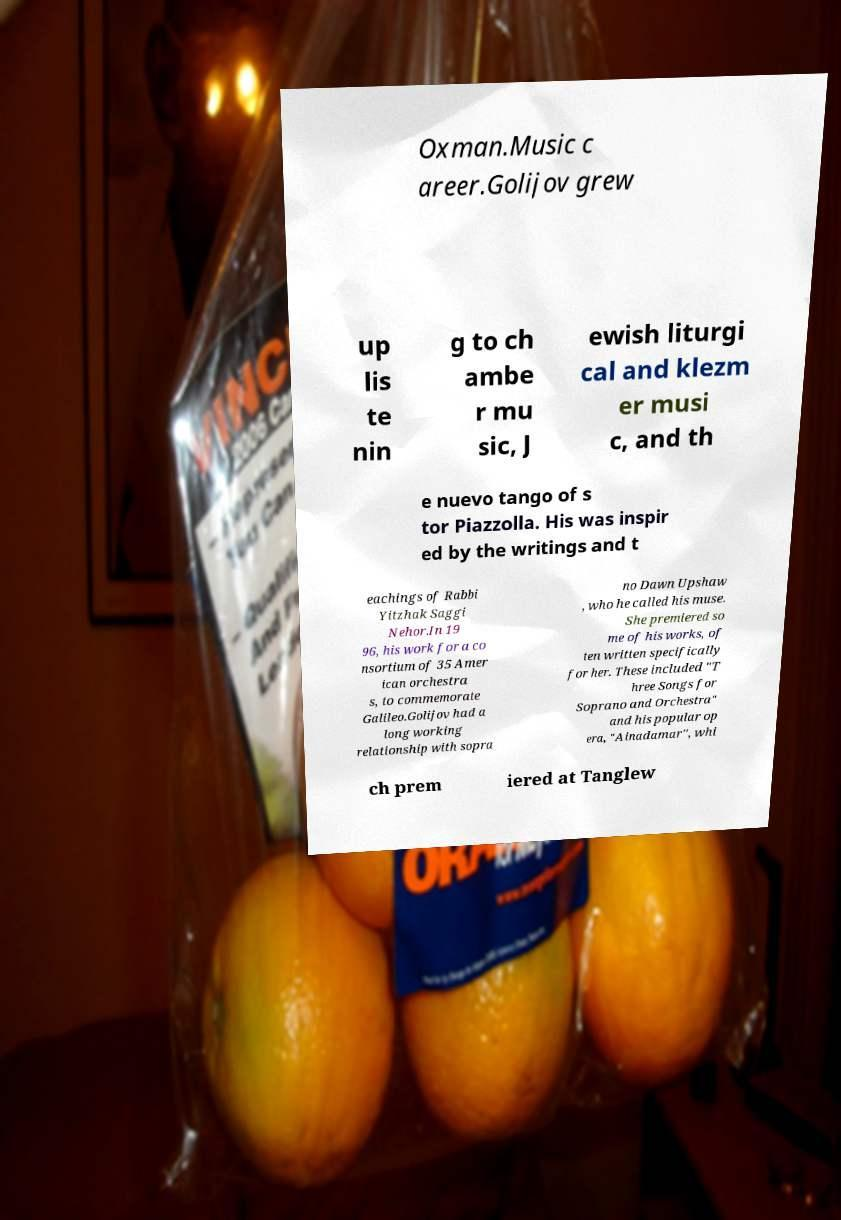Can you read and provide the text displayed in the image?This photo seems to have some interesting text. Can you extract and type it out for me? Oxman.Music c areer.Golijov grew up lis te nin g to ch ambe r mu sic, J ewish liturgi cal and klezm er musi c, and th e nuevo tango of s tor Piazzolla. His was inspir ed by the writings and t eachings of Rabbi Yitzhak Saggi Nehor.In 19 96, his work for a co nsortium of 35 Amer ican orchestra s, to commemorate Galileo.Golijov had a long working relationship with sopra no Dawn Upshaw , who he called his muse. She premiered so me of his works, of ten written specifically for her. These included "T hree Songs for Soprano and Orchestra" and his popular op era, "Ainadamar", whi ch prem iered at Tanglew 